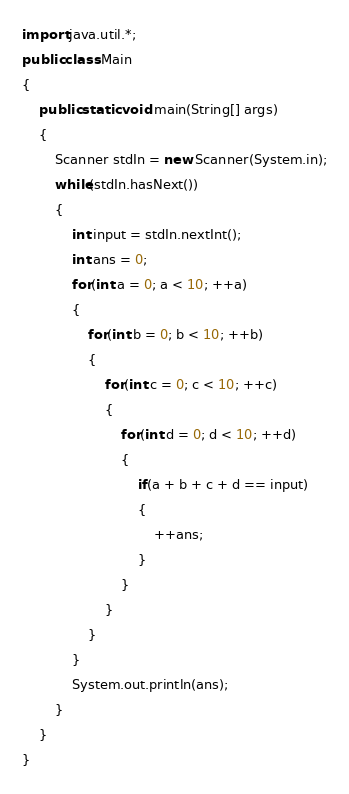<code> <loc_0><loc_0><loc_500><loc_500><_Java_>import java.util.*;
public class Main 
{
	public static void main(String[] args) 
	{
		Scanner stdIn = new Scanner(System.in);
		while(stdIn.hasNext())
		{
			int input = stdIn.nextInt();
			int ans = 0;
			for(int a = 0; a < 10; ++a)
			{
				for(int b = 0; b < 10; ++b)
				{
					for(int c = 0; c < 10; ++c)
					{
						for(int d = 0; d < 10; ++d)
						{
							if(a + b + c + d == input)
							{
								++ans;
							}
						}
					}
				}
			}
			System.out.println(ans);
		}
	}
}</code> 